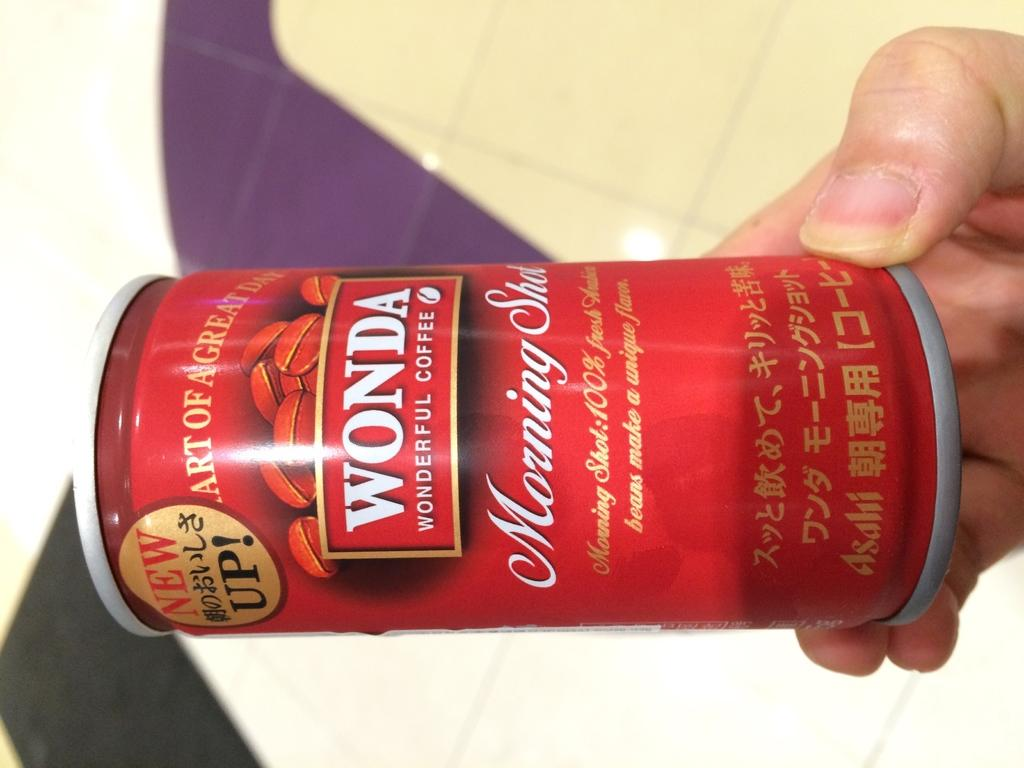<image>
Share a concise interpretation of the image provided. A hand holding a red Wonda branded can of coffee gorunds. 